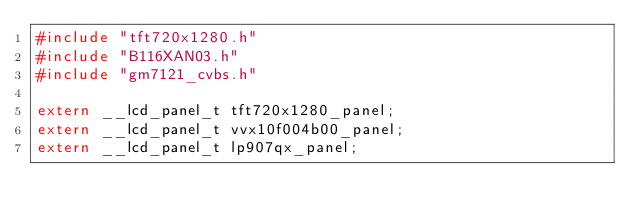Convert code to text. <code><loc_0><loc_0><loc_500><loc_500><_C_>#include "tft720x1280.h"
#include "B116XAN03.h"
#include "gm7121_cvbs.h"

extern __lcd_panel_t tft720x1280_panel;
extern __lcd_panel_t vvx10f004b00_panel;
extern __lcd_panel_t lp907qx_panel;</code> 